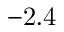<formula> <loc_0><loc_0><loc_500><loc_500>- 2 . 4</formula> 